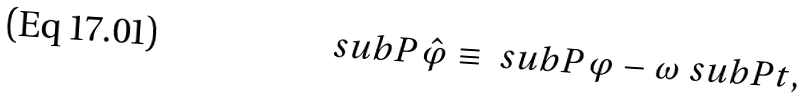<formula> <loc_0><loc_0><loc_500><loc_500>\ s u b P { \hat { \varphi } } \equiv \ s u b P { \varphi } - \omega \ s u b P { t } ,</formula> 